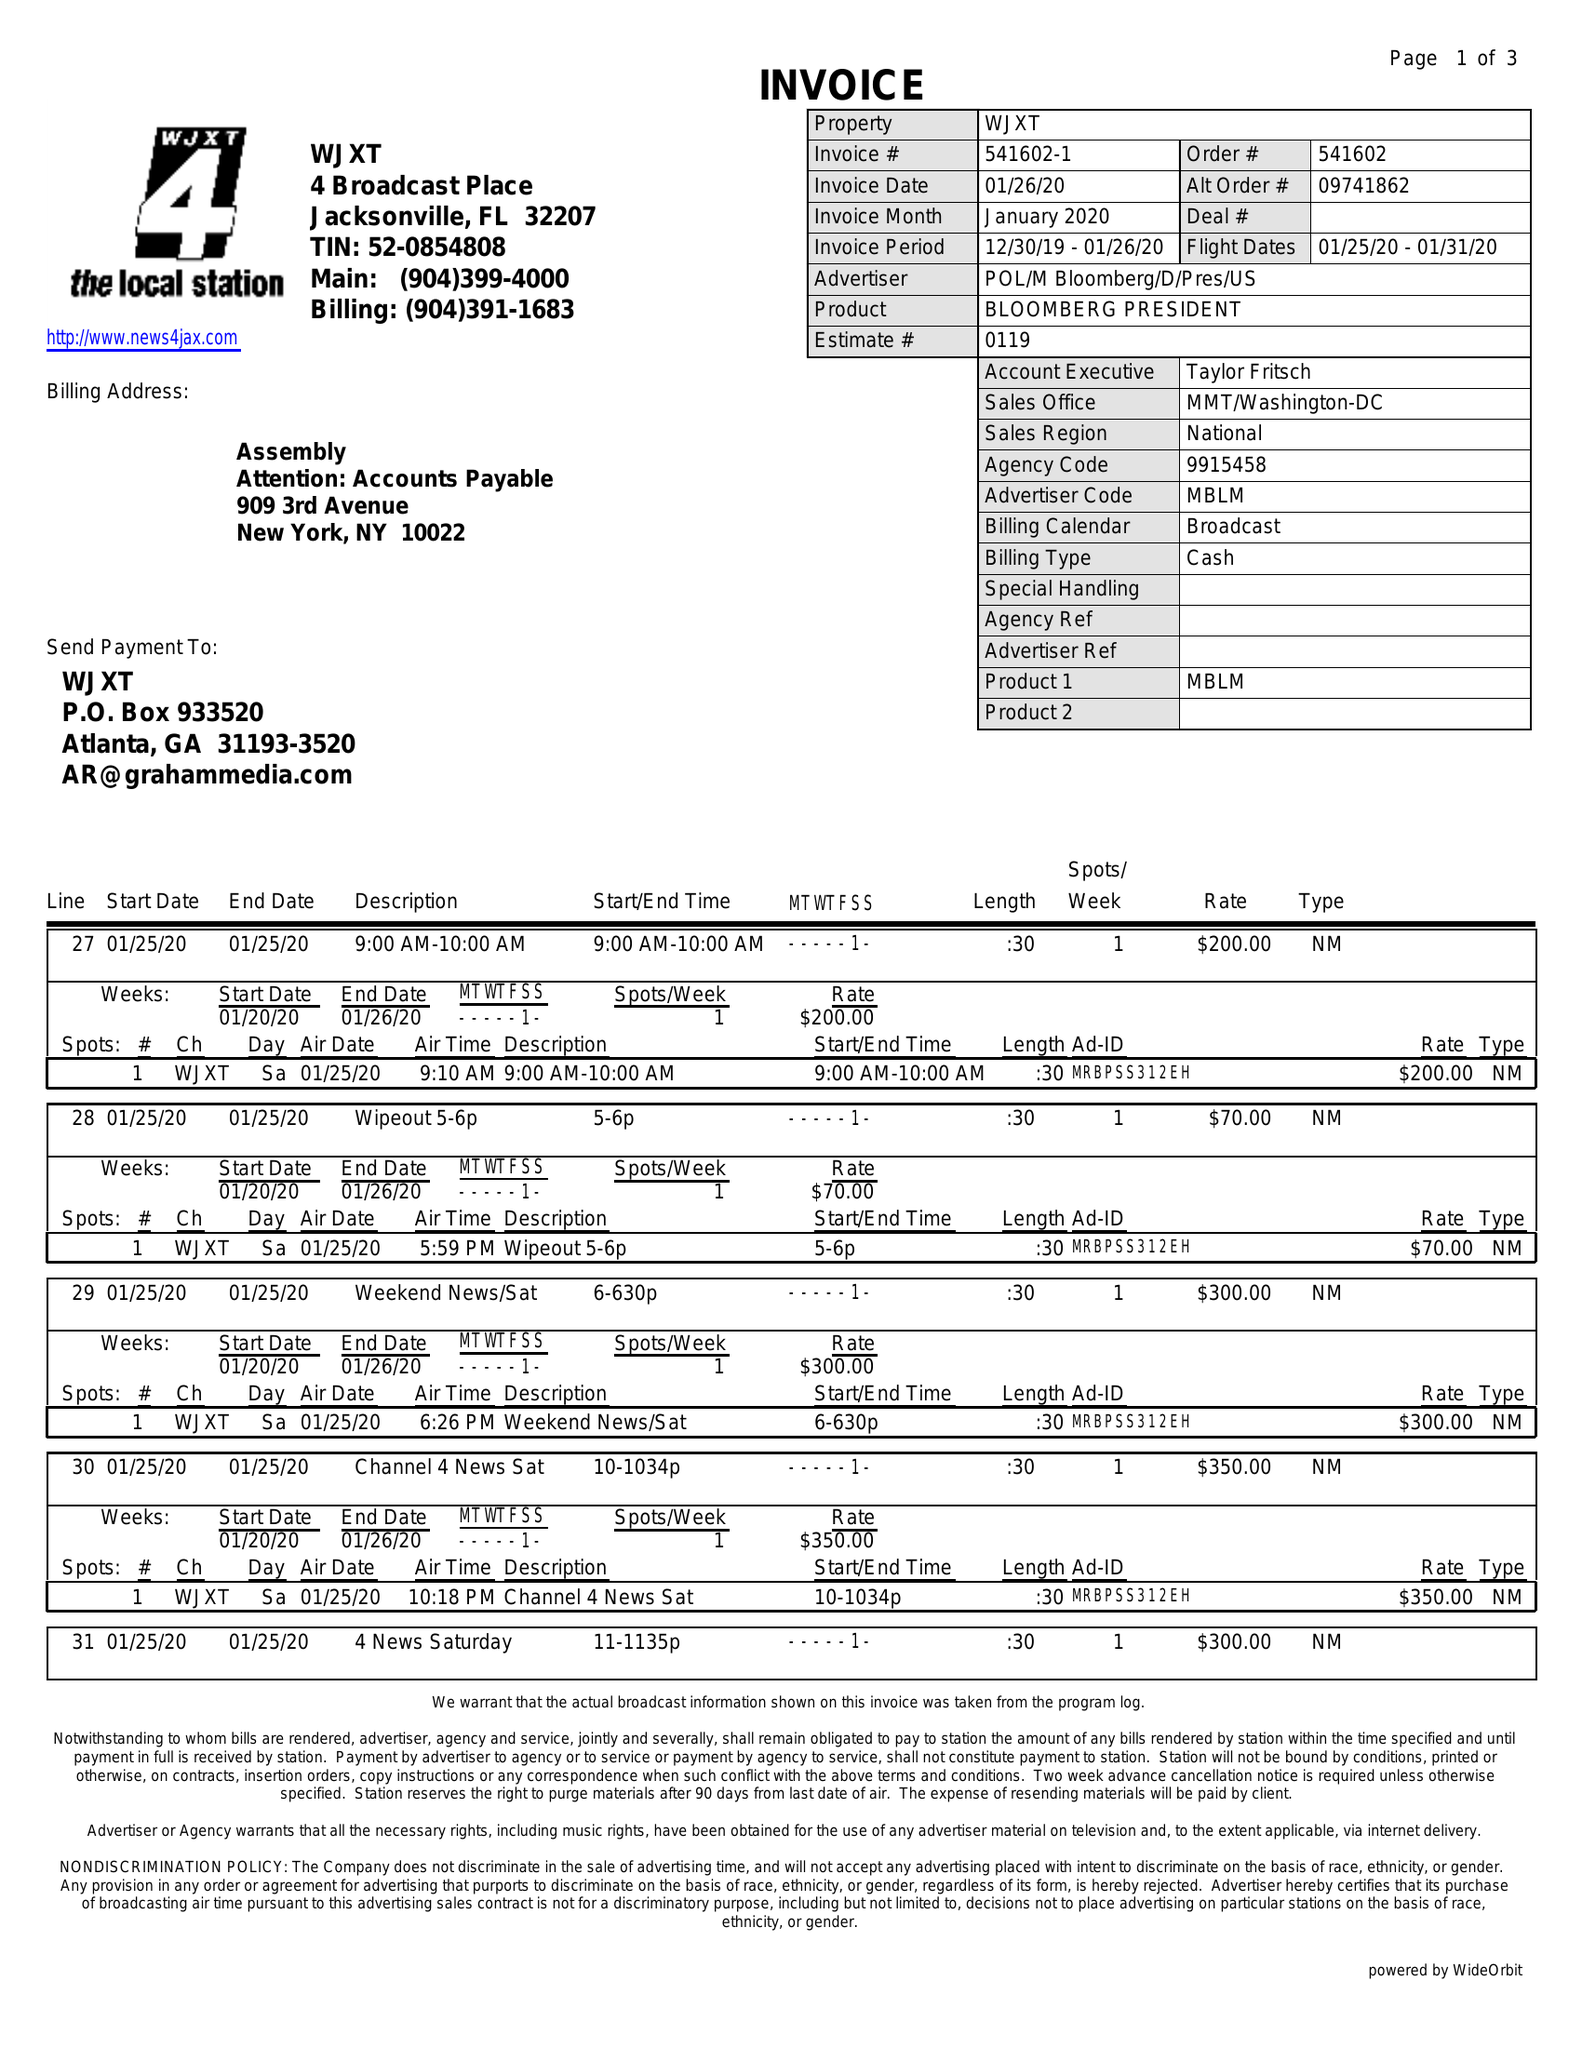What is the value for the gross_amount?
Answer the question using a single word or phrase. 2690.00 